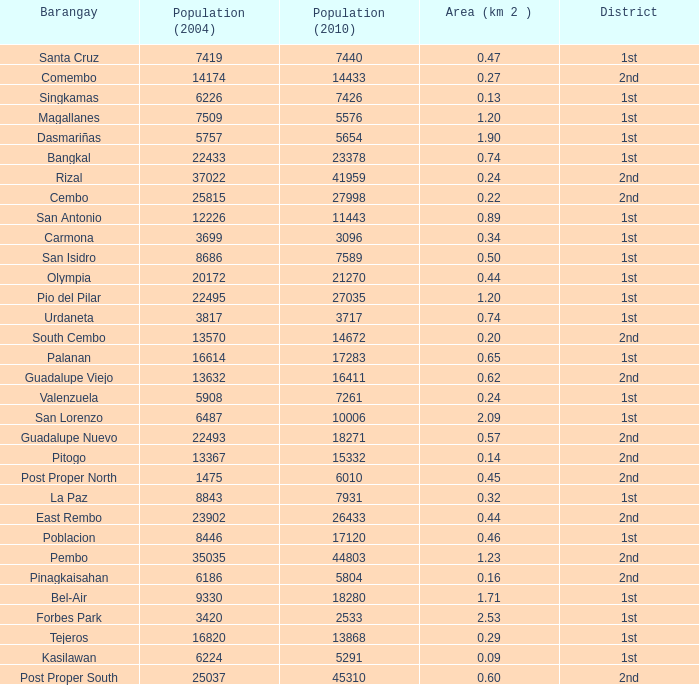What is the area where barangay is guadalupe viejo? 0.62. 